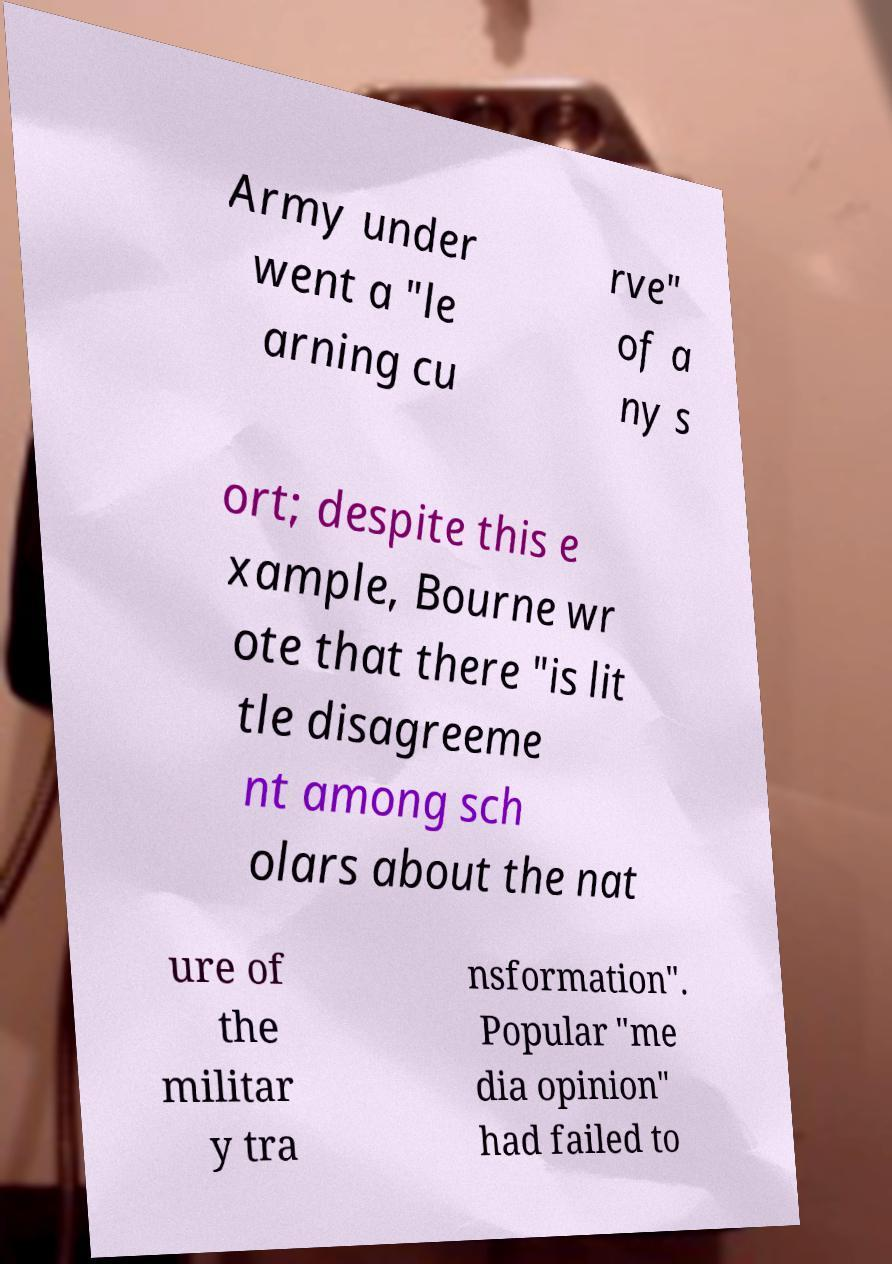Please read and relay the text visible in this image. What does it say? Army under went a "le arning cu rve" of a ny s ort; despite this e xample, Bourne wr ote that there "is lit tle disagreeme nt among sch olars about the nat ure of the militar y tra nsformation". Popular "me dia opinion" had failed to 